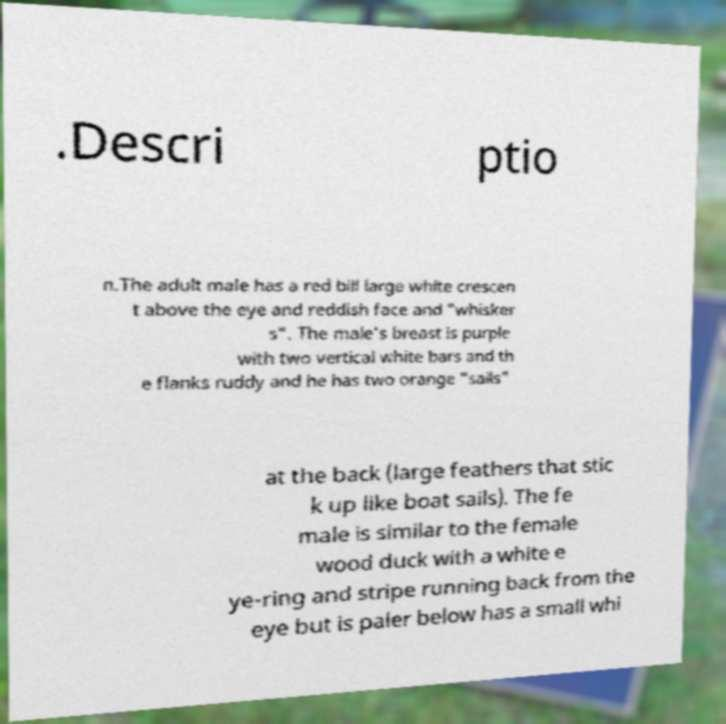I need the written content from this picture converted into text. Can you do that? .Descri ptio n.The adult male has a red bill large white crescen t above the eye and reddish face and "whisker s". The male's breast is purple with two vertical white bars and th e flanks ruddy and he has two orange "sails" at the back (large feathers that stic k up like boat sails). The fe male is similar to the female wood duck with a white e ye-ring and stripe running back from the eye but is paler below has a small whi 